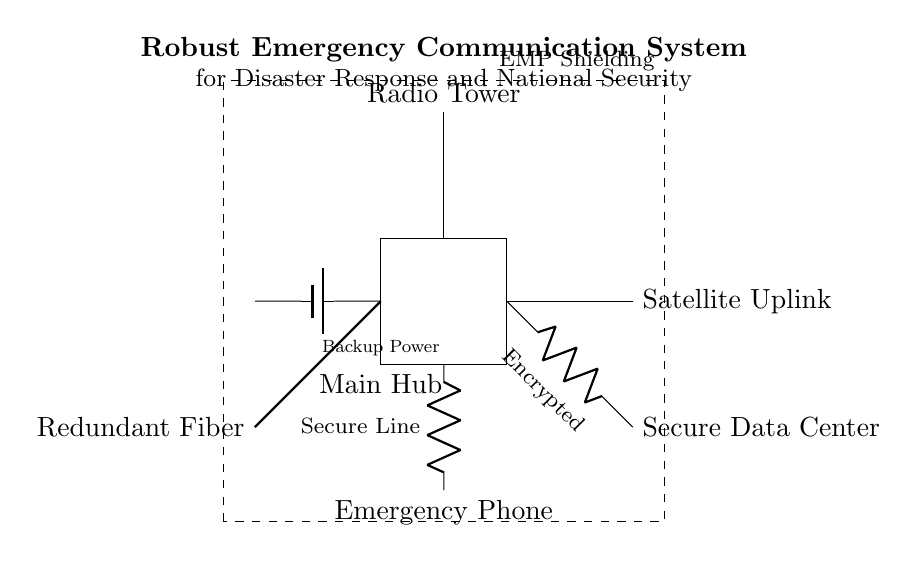What is the main component of this circuit? The main component is the "Main Hub," which serves as the central point for communication. It is visually placed at the center of the diagram and connects various elements.
Answer: Main Hub What power source is used for backup? The backup power source is a "Battery." In the diagram, there is a symbol representing a battery labeled "Backup Power."
Answer: Battery What type of data link is depicted in the circuit? The data link is "Encrypted." The diagram specifically shows a connection labeled as "Encrypted" between the satellite uplink and the secure data center.
Answer: Encrypted How many communication methods are illustrated in the diagram? There are three communication methods: "Satellite Uplink," "Radio Tower," and "Emergency Phone." Each method is represented by distinct components in the circuit.
Answer: Three What protection is included in the circuit design? The protection included is "EMP Shielding." This is represented by a dashed rectangle surrounding the main components, labeled accordingly.
Answer: EMP Shielding Which line is described as a secure connection? The "Secure Line" is described as a secure connection, represented by a resistor and labeled as such. It connects to the Emergency Phone.
Answer: Secure Line What type of redundancy is shown in the diagram? The redundancy shown is "Fiber Optic." The diagram indicates a redundant fiber optic connection that enhances reliability in communication when other methods fail.
Answer: Fiber Optic 